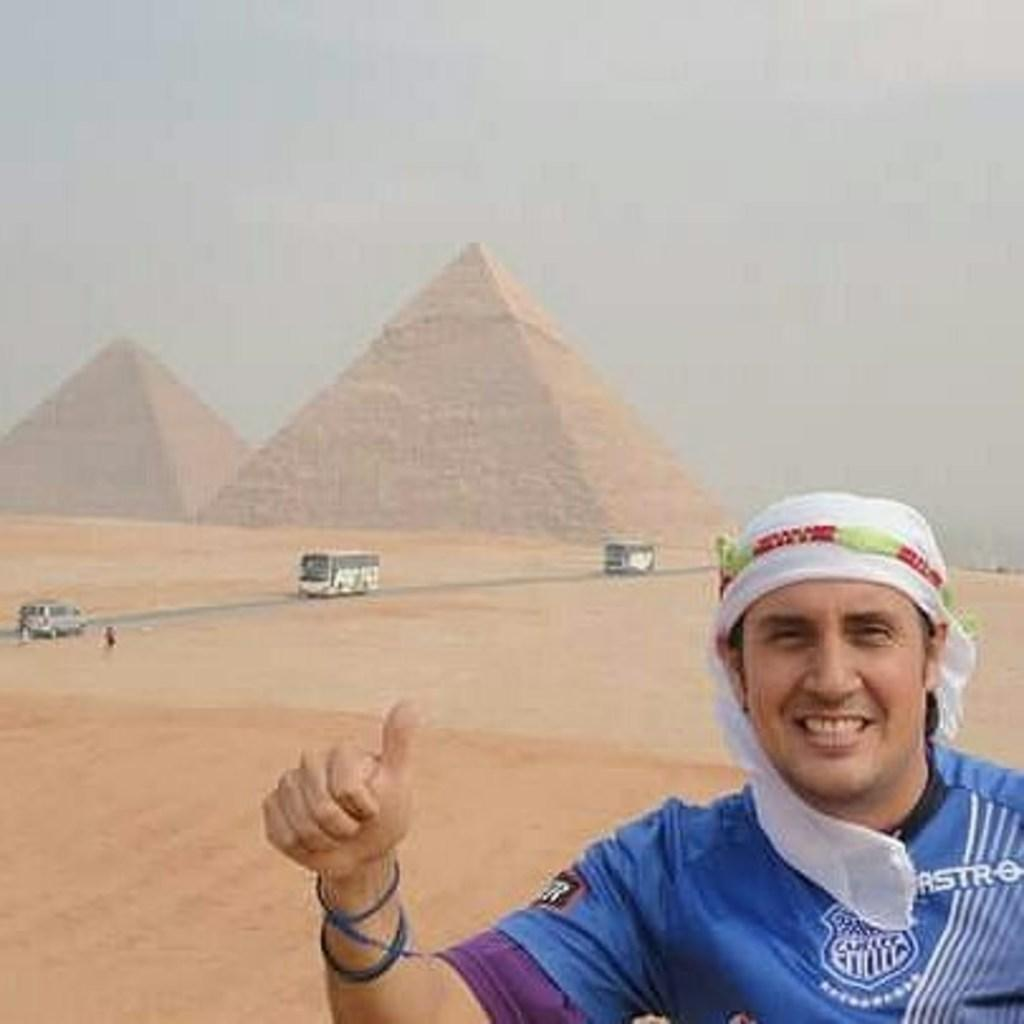Who is present in the image? There is a man in the image. What is the man's expression? The man is smiling. What can be seen in the background of the image? There are vehicles, a desert, structures, and a cloudy sky in the background of the image. What scent can be detected in the image? There is no information about scents in the image, as it only provides visual details. 